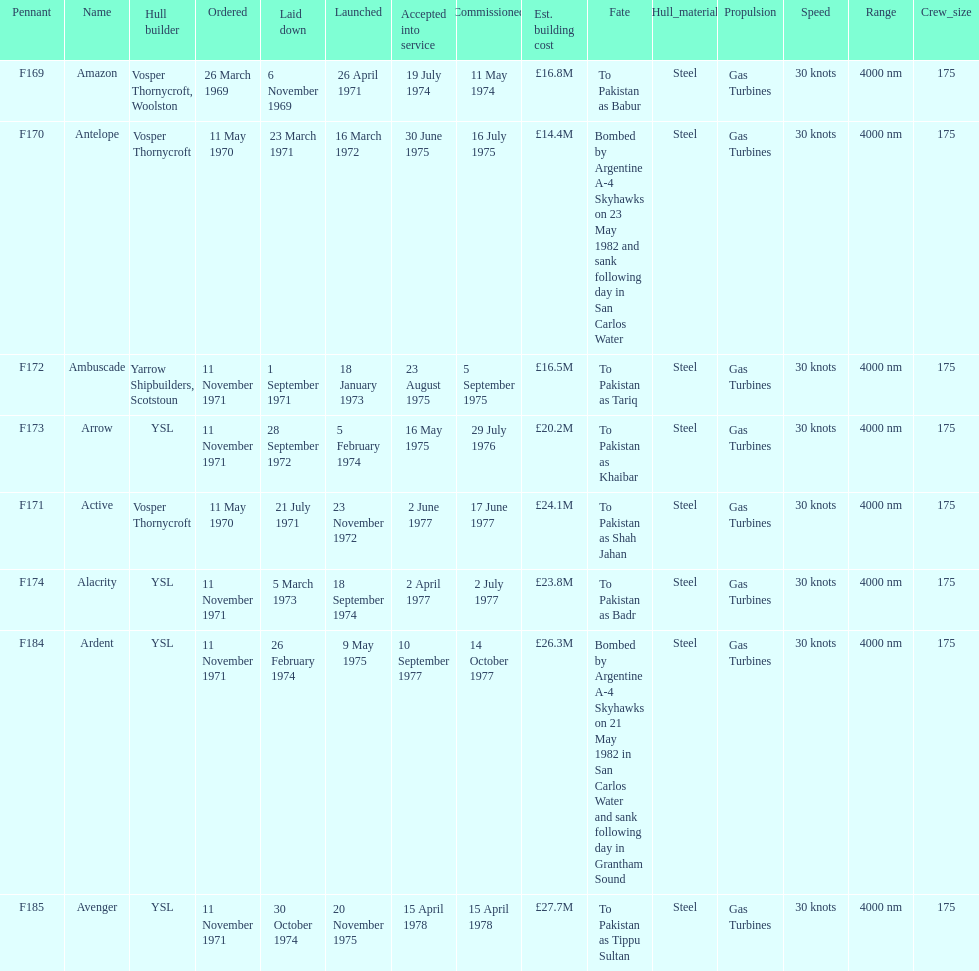Which ship had the highest estimated cost to build? Avenger. 